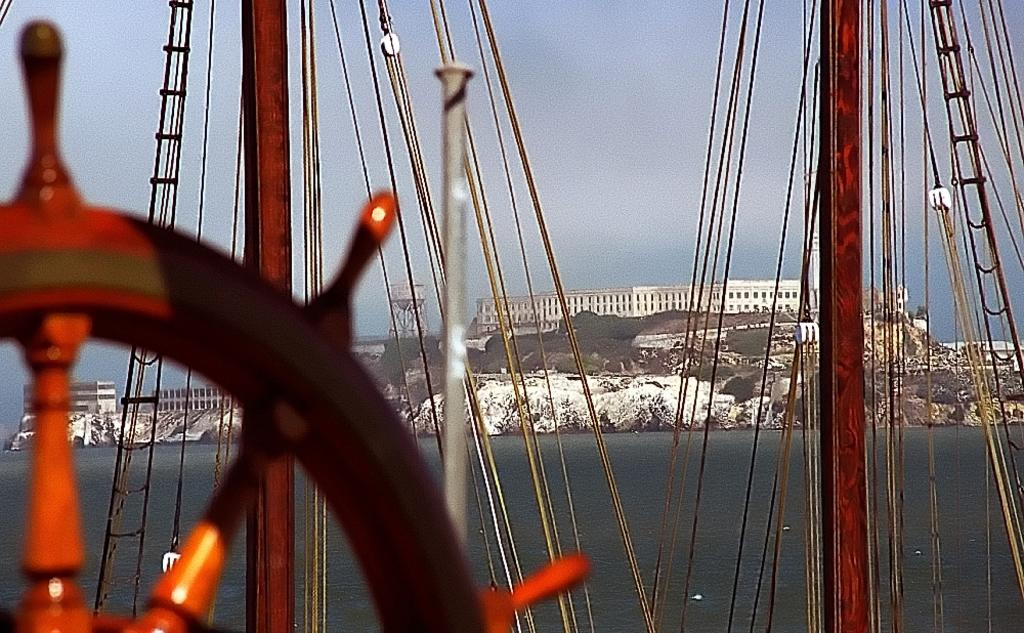What is the main subject in the image? There is a ship in the water in the image. What can be seen in the background of the image? There are buildings, trees, rocks, and the sky visible in the background of the image. What type of beef is being served on the ship in the image? There is no beef or any food visible in the image; it only shows a ship in the water and the background elements. 